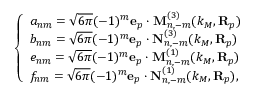<formula> <loc_0><loc_0><loc_500><loc_500>\left \{ \begin{array} { l l } { a _ { n m } = \sqrt { 6 \pi } ( - 1 ) ^ { m } e _ { p } \cdot M _ { n , - m } ^ { ( 3 ) } ( k _ { M } , R _ { p } ) } \\ { b _ { n m } = \sqrt { 6 \pi } ( - 1 ) ^ { m } e _ { p } \cdot N _ { n , - m } ^ { ( 3 ) } ( k _ { M } , R _ { p } ) } \\ { e _ { n m } = \sqrt { 6 \pi } ( - 1 ) ^ { m } e _ { p } \cdot M _ { n , - m } ^ { ( 1 ) } ( k _ { M } , R _ { p } ) } \\ { f _ { n m } = \sqrt { 6 \pi } ( - 1 ) ^ { m } e _ { p } \cdot N _ { n , - m } ^ { ( 1 ) } ( k _ { M } , R _ { p } ) , } \end{array}</formula> 